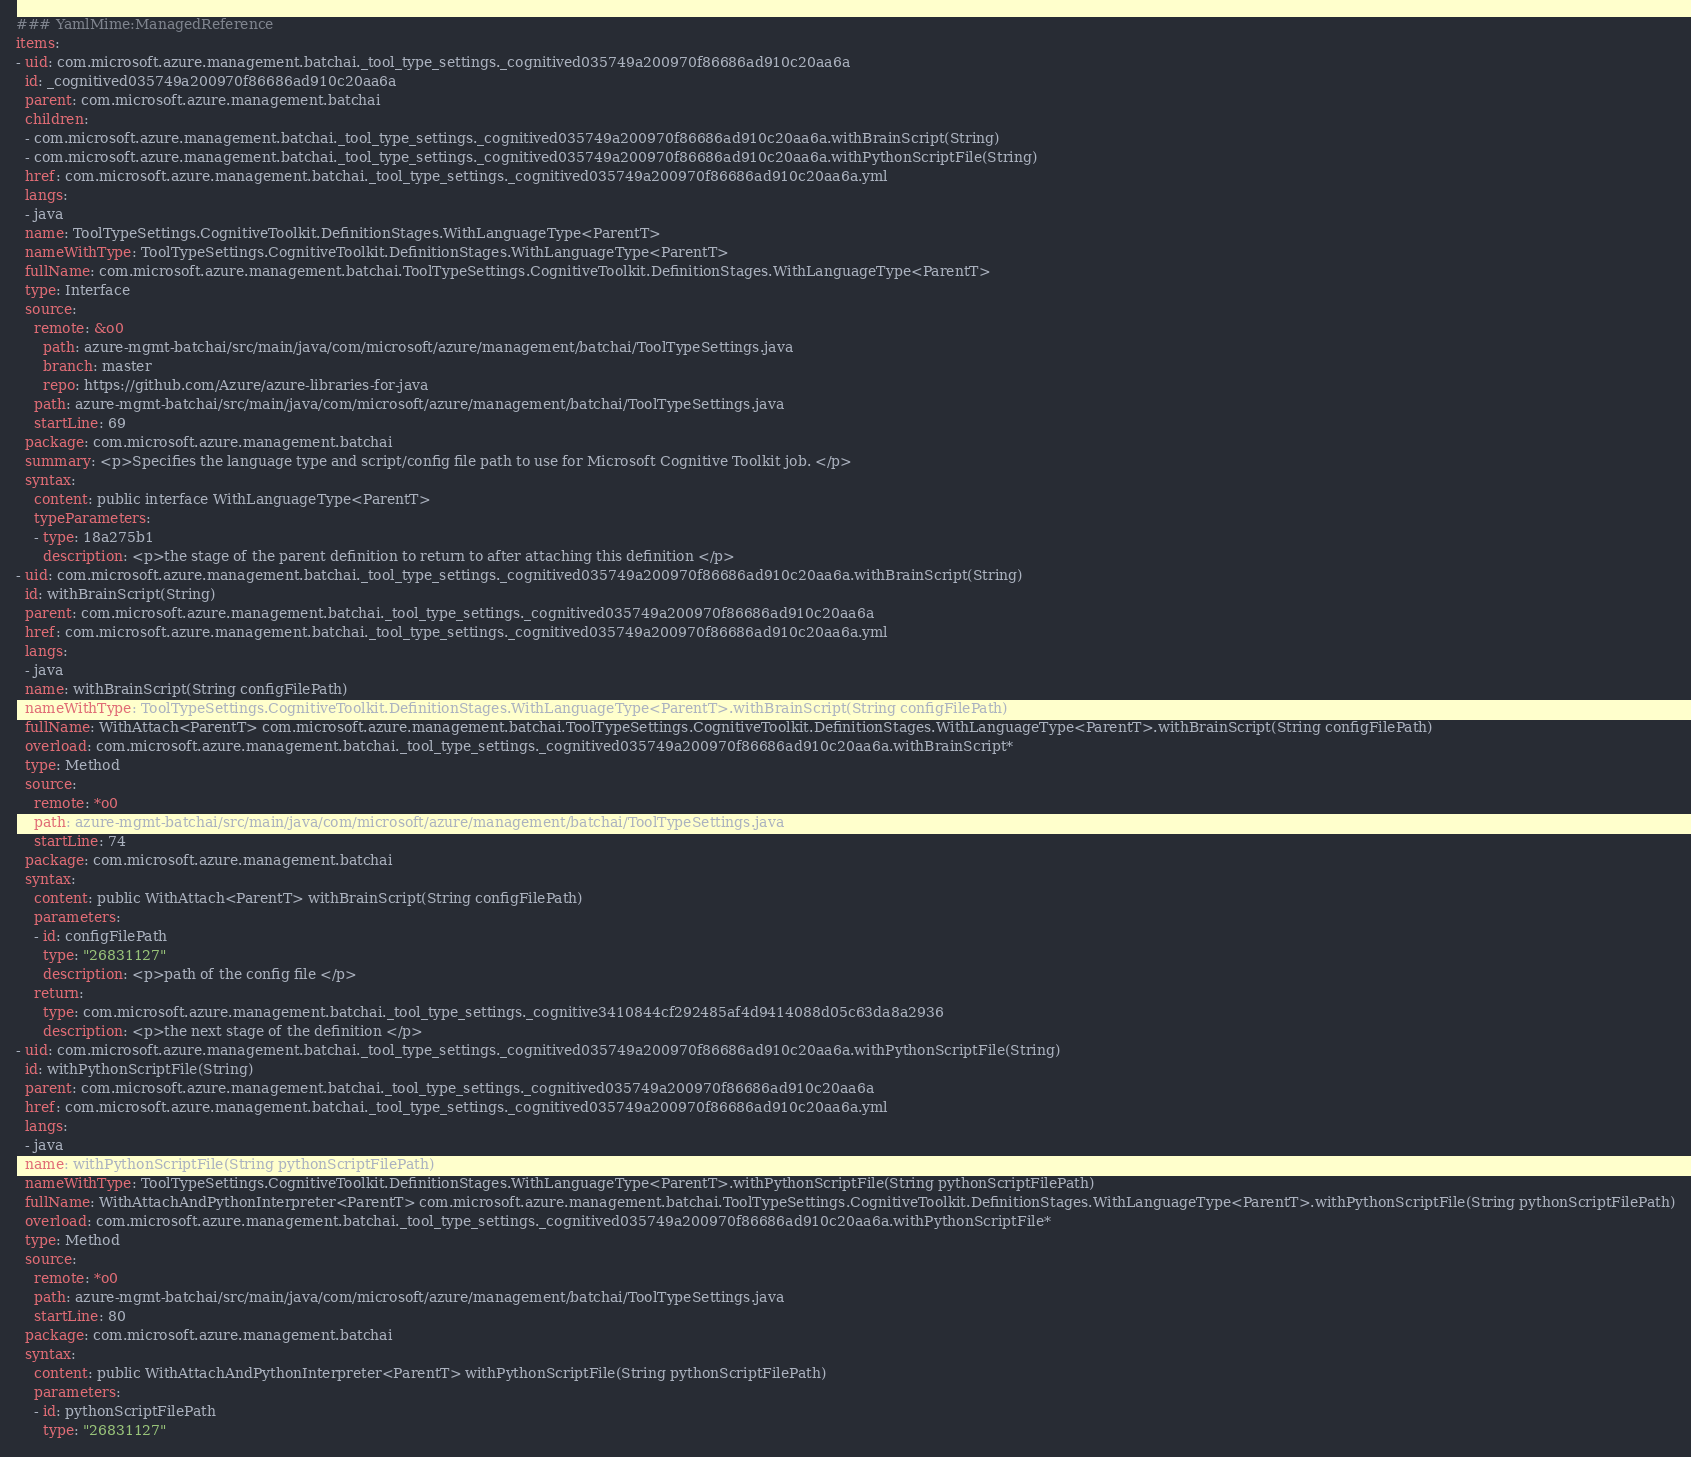<code> <loc_0><loc_0><loc_500><loc_500><_YAML_>### YamlMime:ManagedReference
items:
- uid: com.microsoft.azure.management.batchai._tool_type_settings._cognitived035749a200970f86686ad910c20aa6a
  id: _cognitived035749a200970f86686ad910c20aa6a
  parent: com.microsoft.azure.management.batchai
  children:
  - com.microsoft.azure.management.batchai._tool_type_settings._cognitived035749a200970f86686ad910c20aa6a.withBrainScript(String)
  - com.microsoft.azure.management.batchai._tool_type_settings._cognitived035749a200970f86686ad910c20aa6a.withPythonScriptFile(String)
  href: com.microsoft.azure.management.batchai._tool_type_settings._cognitived035749a200970f86686ad910c20aa6a.yml
  langs:
  - java
  name: ToolTypeSettings.CognitiveToolkit.DefinitionStages.WithLanguageType<ParentT>
  nameWithType: ToolTypeSettings.CognitiveToolkit.DefinitionStages.WithLanguageType<ParentT>
  fullName: com.microsoft.azure.management.batchai.ToolTypeSettings.CognitiveToolkit.DefinitionStages.WithLanguageType<ParentT>
  type: Interface
  source:
    remote: &o0
      path: azure-mgmt-batchai/src/main/java/com/microsoft/azure/management/batchai/ToolTypeSettings.java
      branch: master
      repo: https://github.com/Azure/azure-libraries-for-java
    path: azure-mgmt-batchai/src/main/java/com/microsoft/azure/management/batchai/ToolTypeSettings.java
    startLine: 69
  package: com.microsoft.azure.management.batchai
  summary: <p>Specifies the language type and script/config file path to use for Microsoft Cognitive Toolkit job. </p>
  syntax:
    content: public interface WithLanguageType<ParentT>
    typeParameters:
    - type: 18a275b1
      description: <p>the stage of the parent definition to return to after attaching this definition </p>
- uid: com.microsoft.azure.management.batchai._tool_type_settings._cognitived035749a200970f86686ad910c20aa6a.withBrainScript(String)
  id: withBrainScript(String)
  parent: com.microsoft.azure.management.batchai._tool_type_settings._cognitived035749a200970f86686ad910c20aa6a
  href: com.microsoft.azure.management.batchai._tool_type_settings._cognitived035749a200970f86686ad910c20aa6a.yml
  langs:
  - java
  name: withBrainScript(String configFilePath)
  nameWithType: ToolTypeSettings.CognitiveToolkit.DefinitionStages.WithLanguageType<ParentT>.withBrainScript(String configFilePath)
  fullName: WithAttach<ParentT> com.microsoft.azure.management.batchai.ToolTypeSettings.CognitiveToolkit.DefinitionStages.WithLanguageType<ParentT>.withBrainScript(String configFilePath)
  overload: com.microsoft.azure.management.batchai._tool_type_settings._cognitived035749a200970f86686ad910c20aa6a.withBrainScript*
  type: Method
  source:
    remote: *o0
    path: azure-mgmt-batchai/src/main/java/com/microsoft/azure/management/batchai/ToolTypeSettings.java
    startLine: 74
  package: com.microsoft.azure.management.batchai
  syntax:
    content: public WithAttach<ParentT> withBrainScript(String configFilePath)
    parameters:
    - id: configFilePath
      type: "26831127"
      description: <p>path of the config file </p>
    return:
      type: com.microsoft.azure.management.batchai._tool_type_settings._cognitive3410844cf292485af4d9414088d05c63da8a2936
      description: <p>the next stage of the definition </p>
- uid: com.microsoft.azure.management.batchai._tool_type_settings._cognitived035749a200970f86686ad910c20aa6a.withPythonScriptFile(String)
  id: withPythonScriptFile(String)
  parent: com.microsoft.azure.management.batchai._tool_type_settings._cognitived035749a200970f86686ad910c20aa6a
  href: com.microsoft.azure.management.batchai._tool_type_settings._cognitived035749a200970f86686ad910c20aa6a.yml
  langs:
  - java
  name: withPythonScriptFile(String pythonScriptFilePath)
  nameWithType: ToolTypeSettings.CognitiveToolkit.DefinitionStages.WithLanguageType<ParentT>.withPythonScriptFile(String pythonScriptFilePath)
  fullName: WithAttachAndPythonInterpreter<ParentT> com.microsoft.azure.management.batchai.ToolTypeSettings.CognitiveToolkit.DefinitionStages.WithLanguageType<ParentT>.withPythonScriptFile(String pythonScriptFilePath)
  overload: com.microsoft.azure.management.batchai._tool_type_settings._cognitived035749a200970f86686ad910c20aa6a.withPythonScriptFile*
  type: Method
  source:
    remote: *o0
    path: azure-mgmt-batchai/src/main/java/com/microsoft/azure/management/batchai/ToolTypeSettings.java
    startLine: 80
  package: com.microsoft.azure.management.batchai
  syntax:
    content: public WithAttachAndPythonInterpreter<ParentT> withPythonScriptFile(String pythonScriptFilePath)
    parameters:
    - id: pythonScriptFilePath
      type: "26831127"</code> 